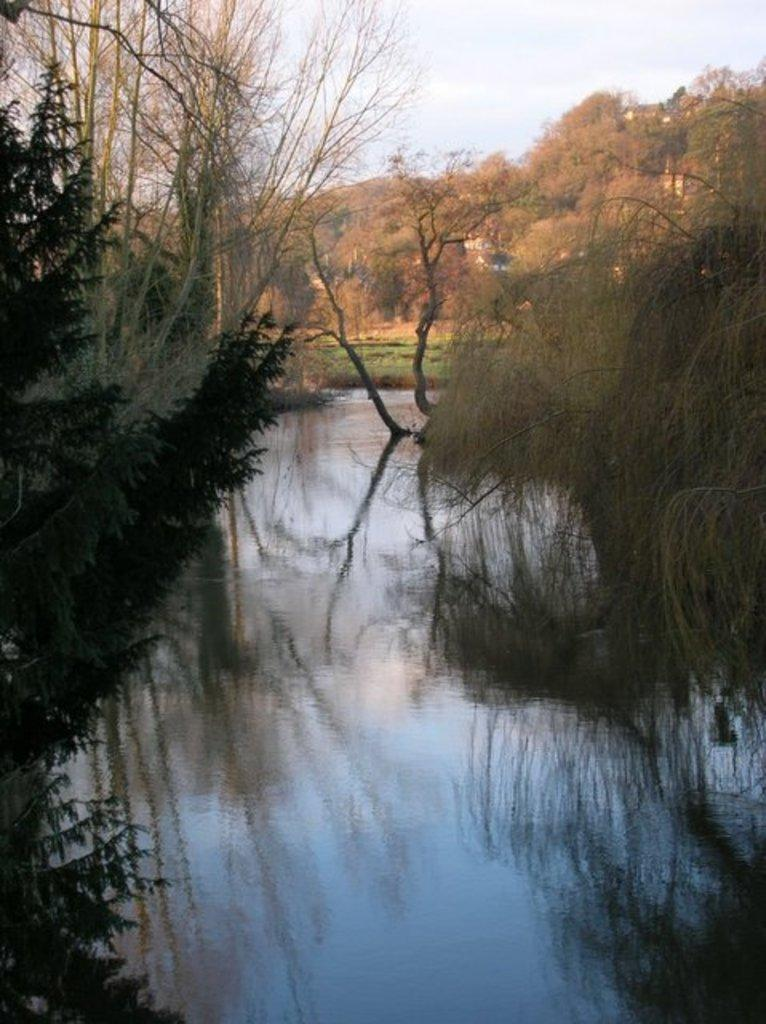What type of vegetation can be seen in the image? There are trees in the image. What is located in the middle of the image? There is water in the middle of the image. What structures can be seen in the background of the image? There are houses in the background of the image. What is visible in the sky in the image? The sky is clear and visible in the background of the image. What type of drug can be seen in the image? There is no drug present in the image. How many geese are visible in the image? There are no geese visible in the image. 